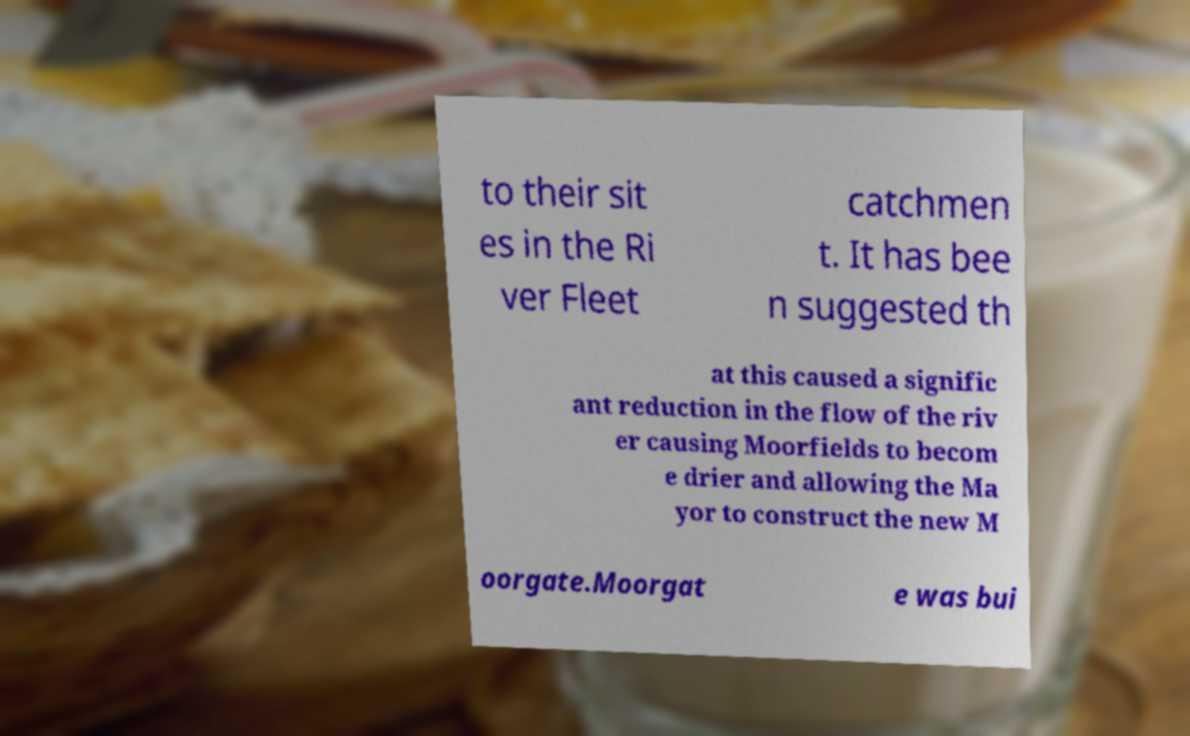Please identify and transcribe the text found in this image. to their sit es in the Ri ver Fleet catchmen t. It has bee n suggested th at this caused a signific ant reduction in the flow of the riv er causing Moorfields to becom e drier and allowing the Ma yor to construct the new M oorgate.Moorgat e was bui 